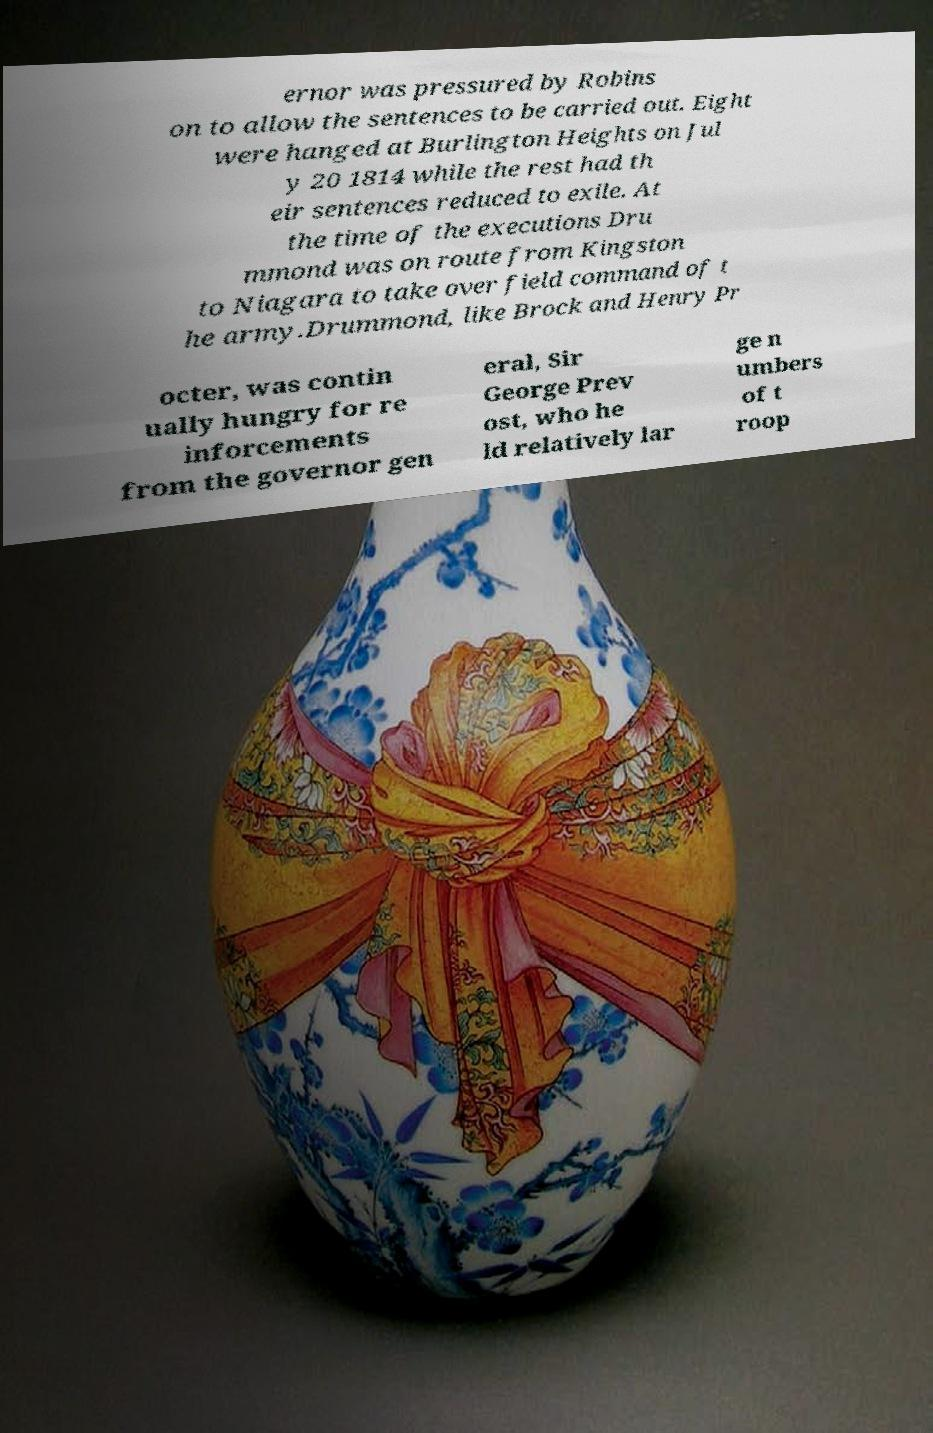Please identify and transcribe the text found in this image. ernor was pressured by Robins on to allow the sentences to be carried out. Eight were hanged at Burlington Heights on Jul y 20 1814 while the rest had th eir sentences reduced to exile. At the time of the executions Dru mmond was on route from Kingston to Niagara to take over field command of t he army.Drummond, like Brock and Henry Pr octer, was contin ually hungry for re inforcements from the governor gen eral, Sir George Prev ost, who he ld relatively lar ge n umbers of t roop 